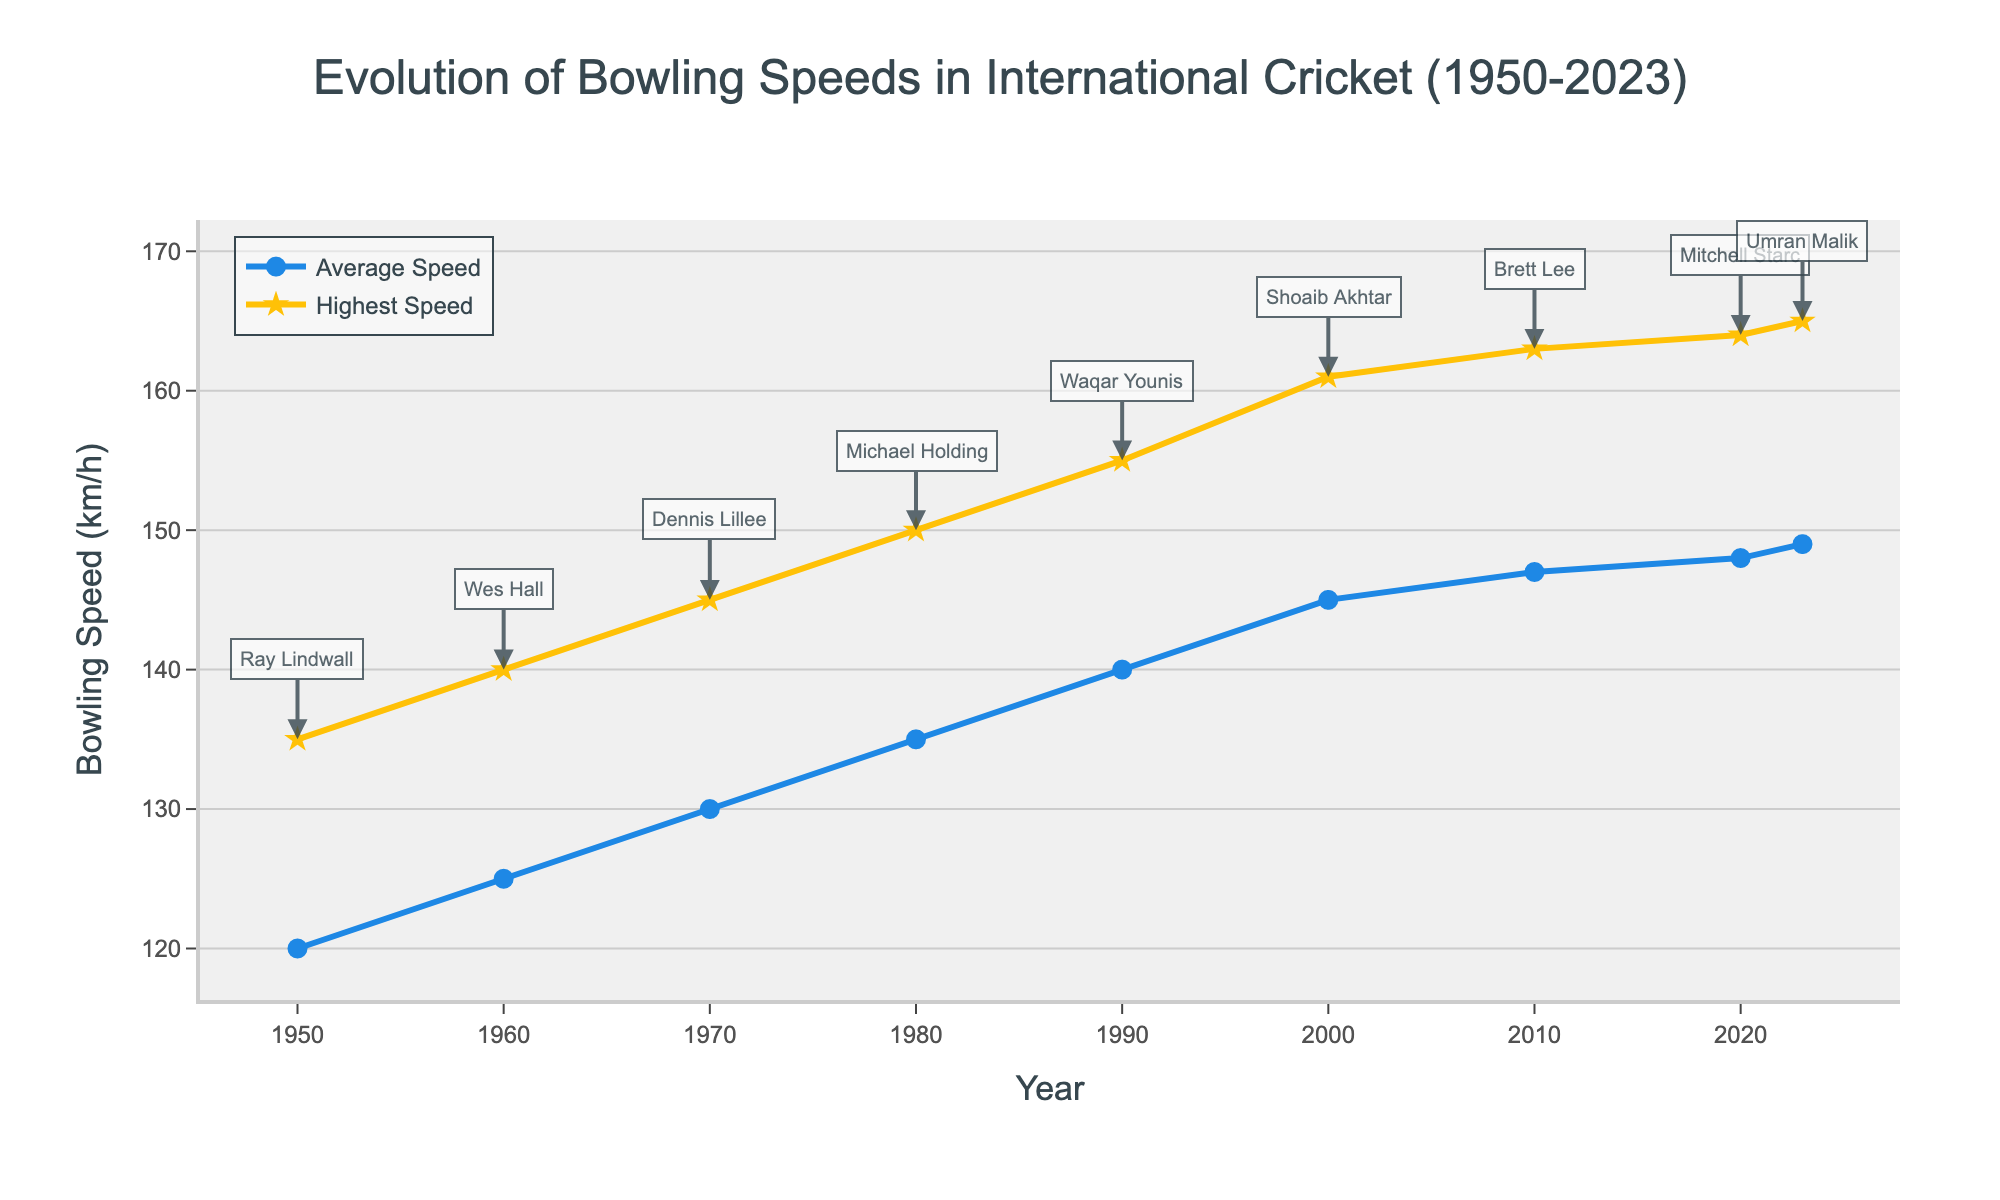What is the highest recorded bowling speed in 2000 and who achieved it? Refer to the point where the highest recorded speed for the year 2000 is marked. The figure shows a star marker at 161 km/h with an annotation pointing to Shoaib Akhtar.
Answer: 161 km/h by Shoaib Akhtar How much did the average fast bowling speed increase from 1950 to 2020? Find the average fast bowling speeds for 1950 and 2020 from the line chart. The speed in 1950 is 120 km/h, and in 2020, it is 148 km/h. The increase is 148 - 120 = 28 km/h.
Answer: 28 km/h Which year shows the smallest difference between the average and highest recorded bowling speeds? Compare the differences between the highest recorded and average speeds for each year. The smallest difference appears in 1950, where 135 km/h (highest) - 120 km/h (average) = 15 km/h.
Answer: 1950 What trend can you observe in the highest recorded bowling speeds from 1950 to 2023? Look at the overall trajectory of the line representing the highest recorded speed. The trend shows a steady increase over the years, reaching a peak of 165 km/h in 2023.
Answer: Steadily increasing trend How does the speed of Brett Lee in 2010 compare to the speed of Waqar Younis in 1990? Compare the annotations and the marker positions for both years. Brett Lee's speed in 2010 is recorded at 163 km/h, while Waqar Younis's speed in 1990 is 155 km/h. Brett Lee's speed is higher.
Answer: Brett Lee's speed is higher What is the average increase in the highest recorded bowling speed per decade from 1950 to 2020? Calculate the increase for each decade, then find the average. Example: From 1950 to 1960, the increase is 5 km/h (140-135). Continue for each decade until 2020, sum these increases and divide by the number of decades (7). (5 + 5 + 5 + 5 + 6 + 2 + 1) / 7 ≈ 4.14 km/h per decade.
Answer: ~4.14 km/h per decade Who achieved the highest recorded bowling speed? Find the data point with the highest value on the chart for highest recorded speeds. The 165 km/h speed in 2023 is achieved by Umran Malik.
Answer: Umran Malik What is the difference between the highest recorded speed and the average speed in 1980? Locate the speeds in 1980: highest recorded speed is 150 km/h, and average speed is 135 km/h. Subtract the average from the highest: 150 - 135 = 15 km/h.
Answer: 15 km/h Which color represents the average fast bowling speed on the chart? Look at the legends or the line colors on the chart. The average fast bowling speed is represented by a blue line.
Answer: Blue 